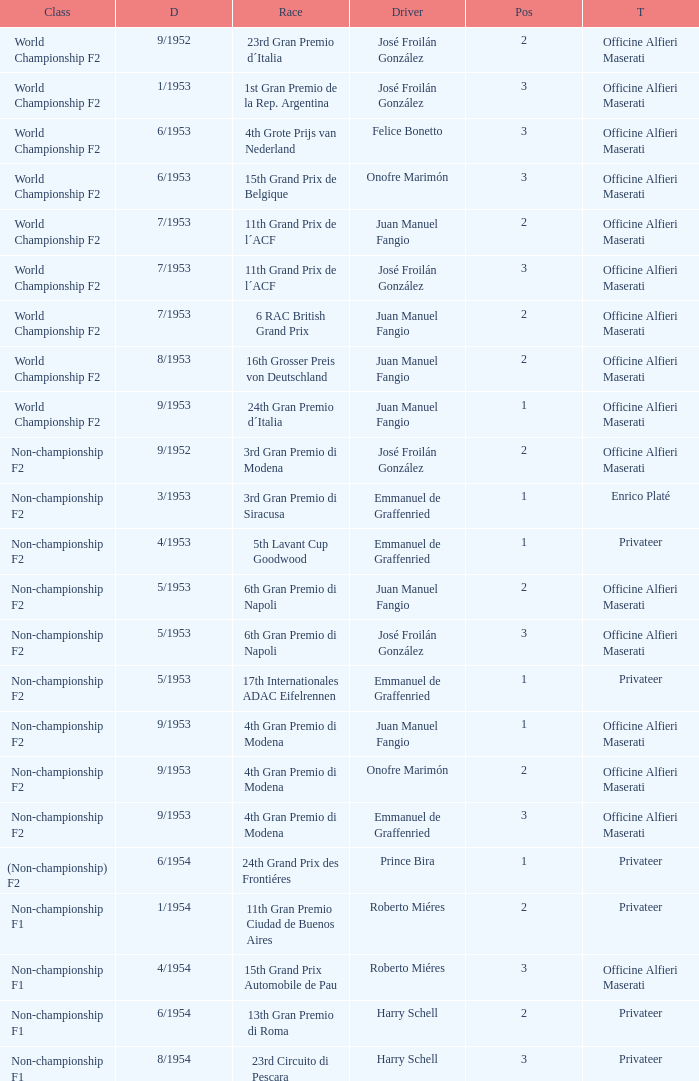What driver has a team of officine alfieri maserati and belongs to the class of non-championship f2 and has a position of 2, as well as a date of 9/1952? José Froilán González. 